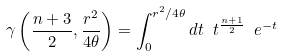Convert formula to latex. <formula><loc_0><loc_0><loc_500><loc_500>\gamma \left ( \frac { n + 3 } { 2 } , \frac { r ^ { 2 } } { 4 \theta } \right ) = \int _ { 0 } ^ { r ^ { 2 } / 4 \theta } d t \ t ^ { \frac { n + 1 } { 2 } } \ e ^ { - t }</formula> 